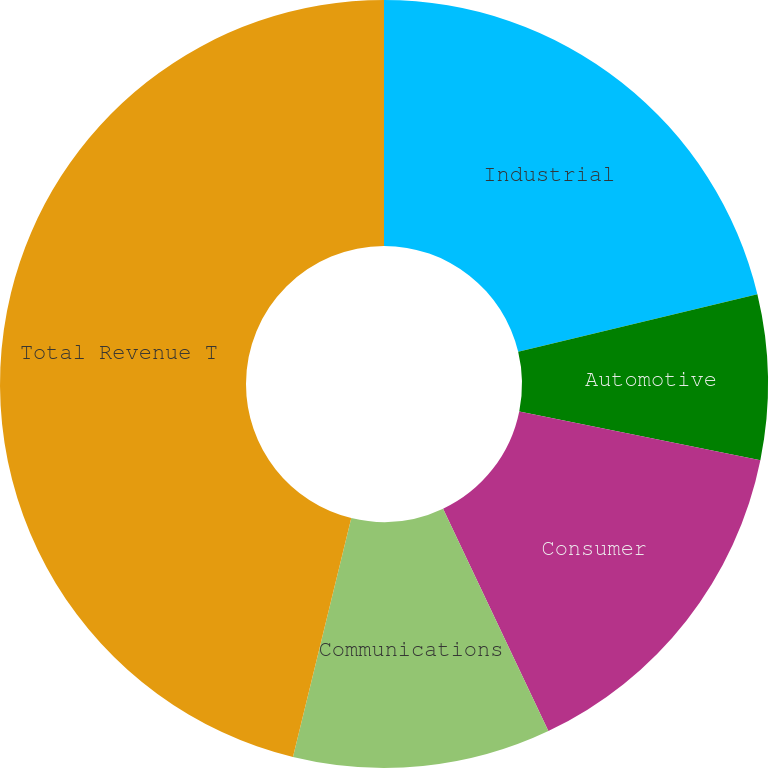Convert chart to OTSL. <chart><loc_0><loc_0><loc_500><loc_500><pie_chart><fcel>Industrial<fcel>Automotive<fcel>Consumer<fcel>Communications<fcel>Total Revenue T<nl><fcel>21.25%<fcel>6.93%<fcel>14.78%<fcel>10.85%<fcel>46.19%<nl></chart> 